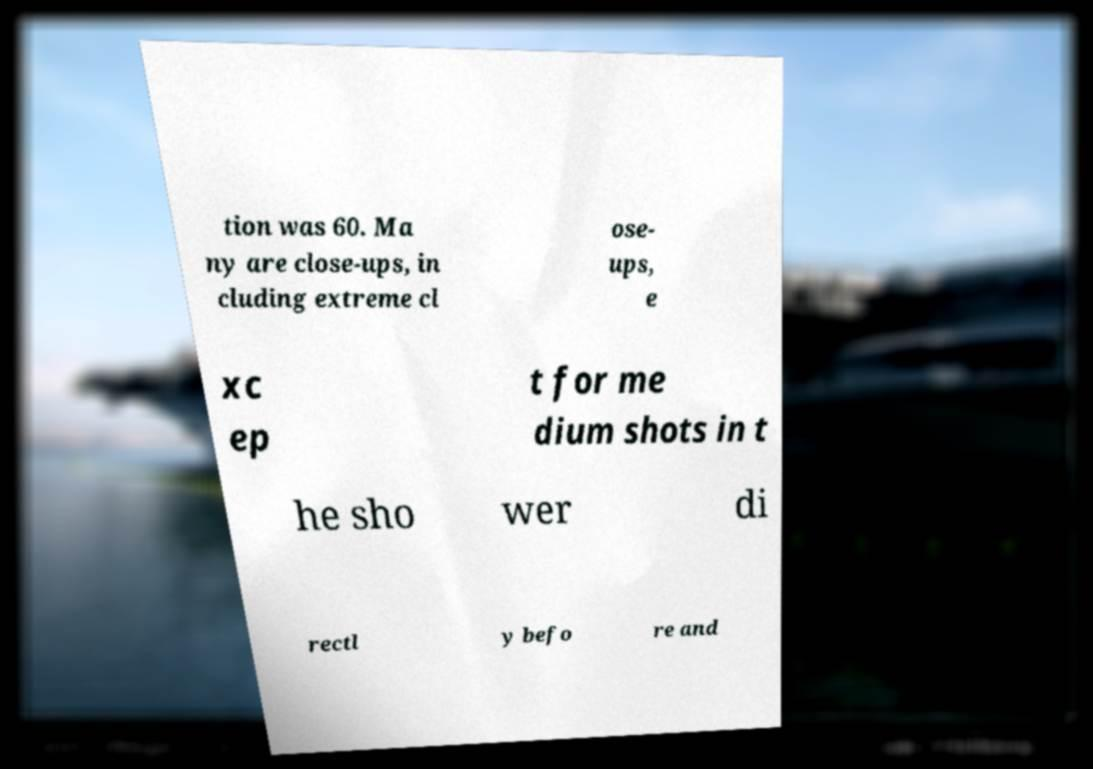There's text embedded in this image that I need extracted. Can you transcribe it verbatim? tion was 60. Ma ny are close-ups, in cluding extreme cl ose- ups, e xc ep t for me dium shots in t he sho wer di rectl y befo re and 